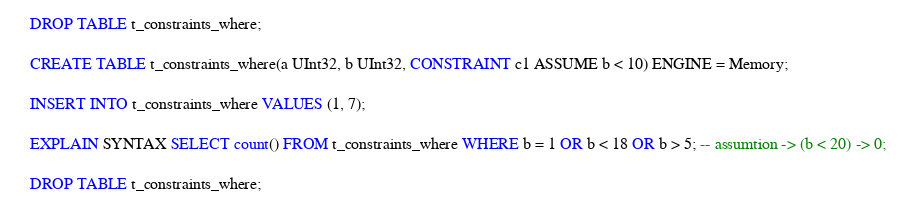<code> <loc_0><loc_0><loc_500><loc_500><_SQL_>DROP TABLE t_constraints_where;

CREATE TABLE t_constraints_where(a UInt32, b UInt32, CONSTRAINT c1 ASSUME b < 10) ENGINE = Memory;

INSERT INTO t_constraints_where VALUES (1, 7);

EXPLAIN SYNTAX SELECT count() FROM t_constraints_where WHERE b = 1 OR b < 18 OR b > 5; -- assumtion -> (b < 20) -> 0;

DROP TABLE t_constraints_where;
</code> 